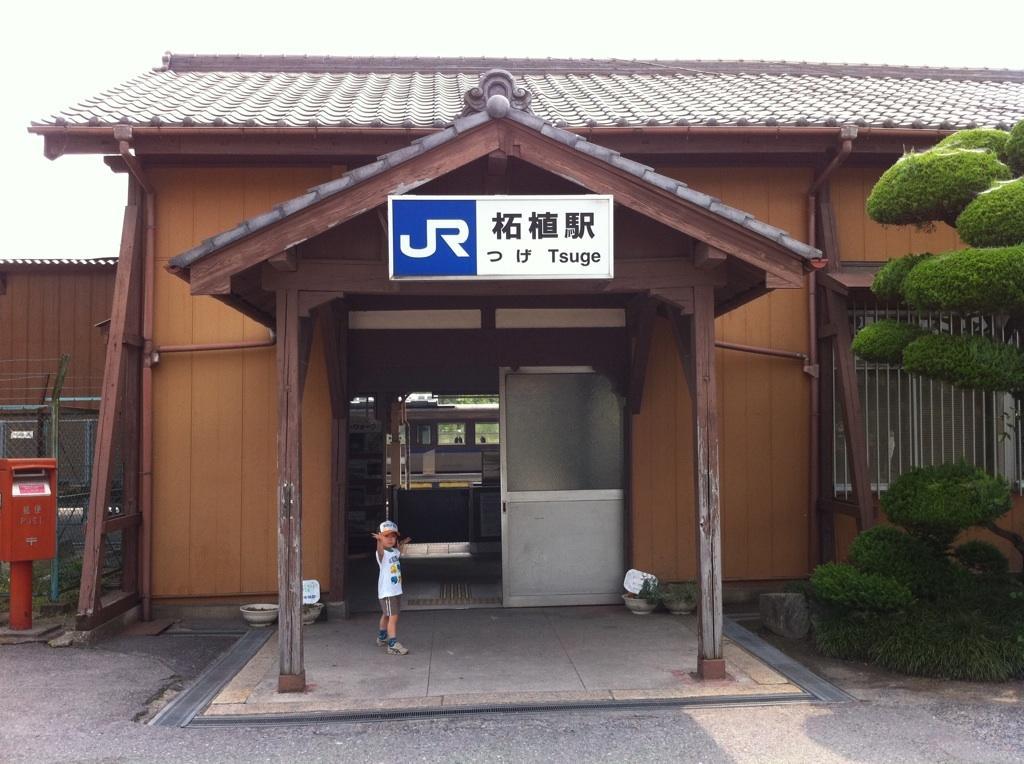Please provide a concise description of this image. In the center of the image we can see a shed. On the right there is a tree and a window. At the bottom there is a boy and we can see a board. On the left there is a post box and a fence. In the background there is sky. 